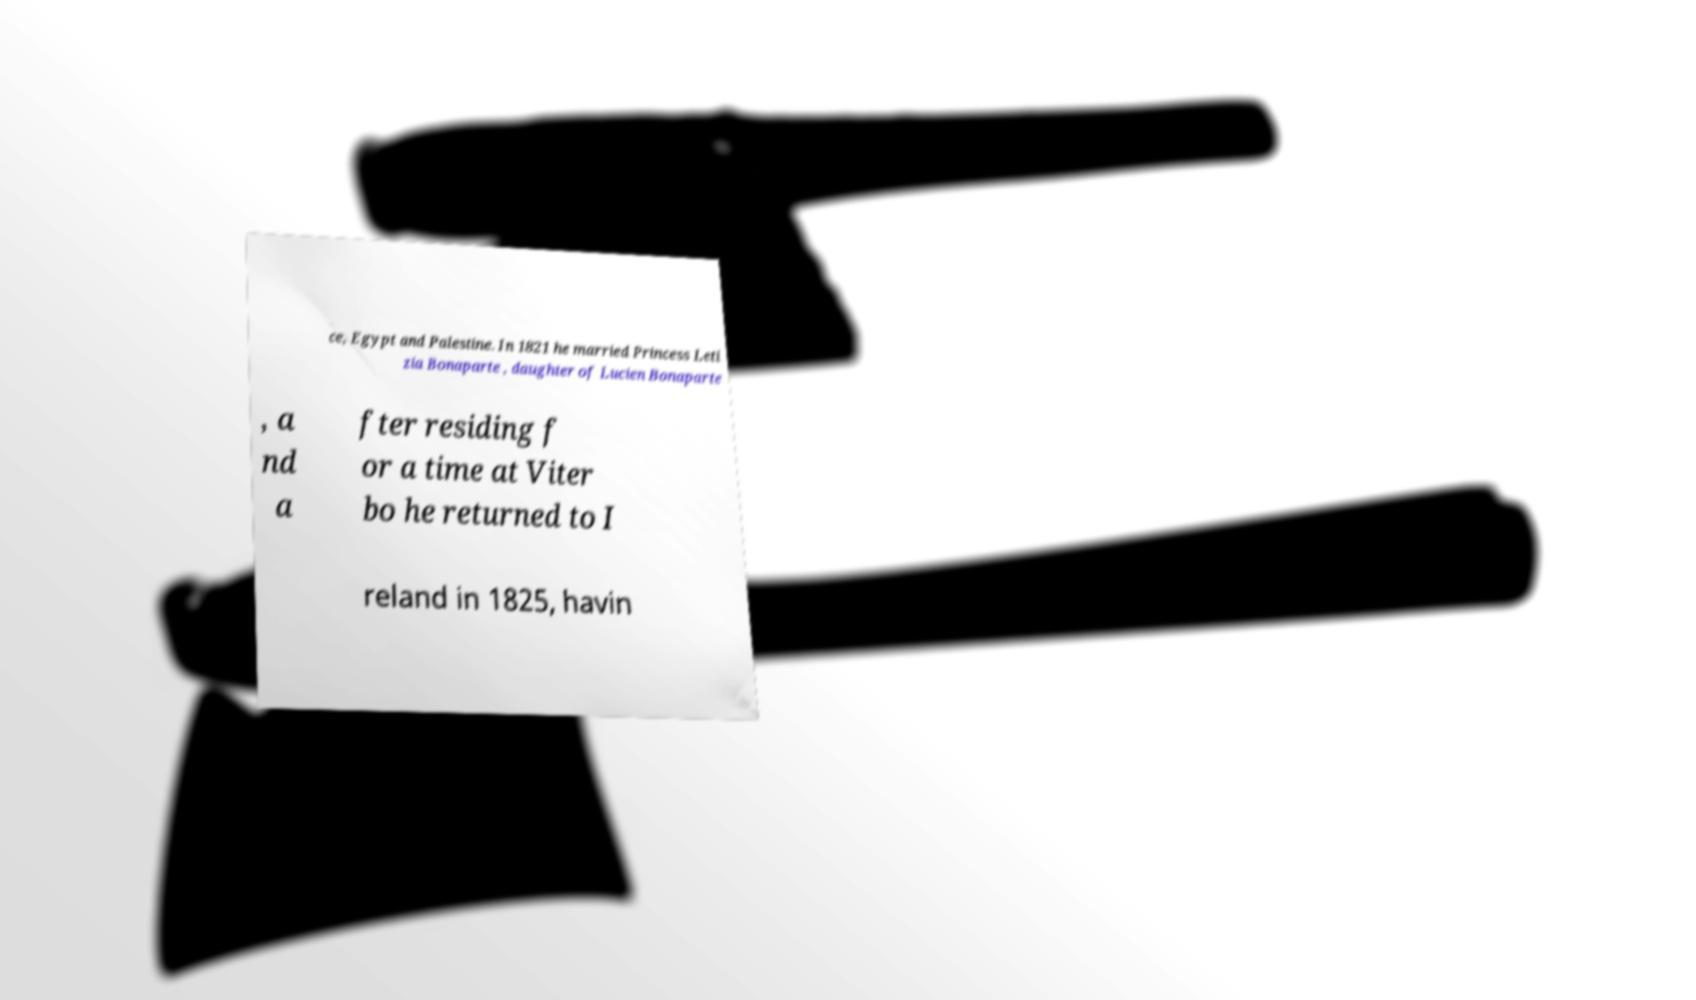Can you accurately transcribe the text from the provided image for me? ce, Egypt and Palestine. In 1821 he married Princess Leti zia Bonaparte , daughter of Lucien Bonaparte , a nd a fter residing f or a time at Viter bo he returned to I reland in 1825, havin 